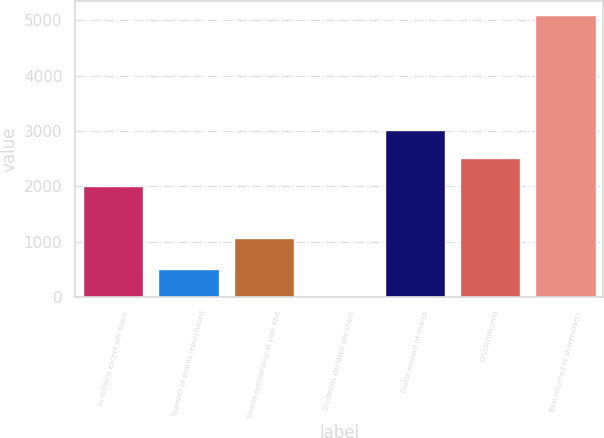<chart> <loc_0><loc_0><loc_500><loc_500><bar_chart><fcel>In millions except per share<fcel>Number of shares repurchased<fcel>Shares outstanding at year end<fcel>Dividends declared per share<fcel>Dollar amount of shares<fcel>Dividends paid<fcel>Total returned to shareholders<nl><fcel>2009<fcel>510.75<fcel>1077<fcel>2.05<fcel>3026.39<fcel>2517.7<fcel>5089<nl></chart> 